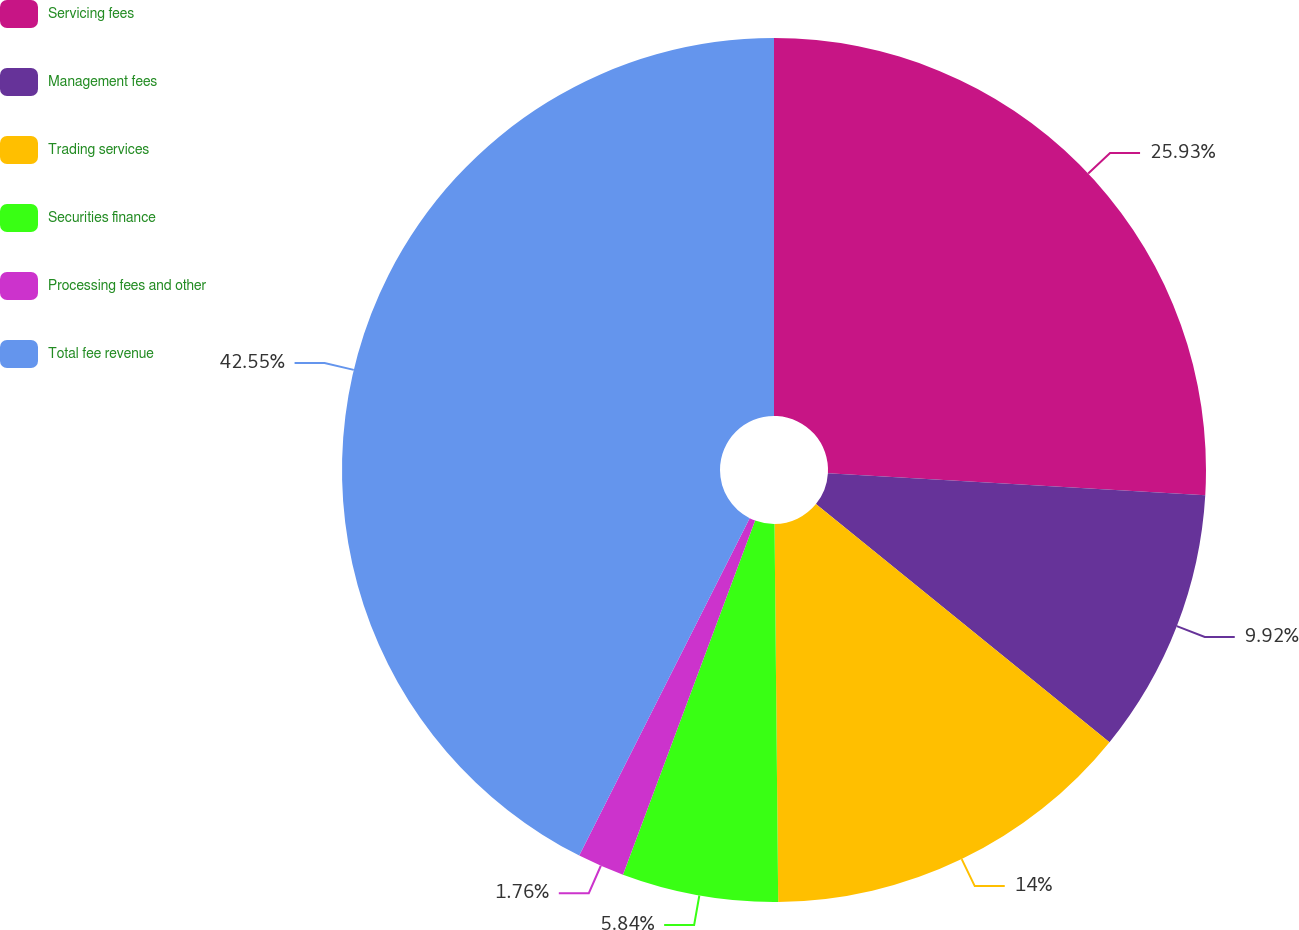<chart> <loc_0><loc_0><loc_500><loc_500><pie_chart><fcel>Servicing fees<fcel>Management fees<fcel>Trading services<fcel>Securities finance<fcel>Processing fees and other<fcel>Total fee revenue<nl><fcel>25.93%<fcel>9.92%<fcel>14.0%<fcel>5.84%<fcel>1.76%<fcel>42.56%<nl></chart> 